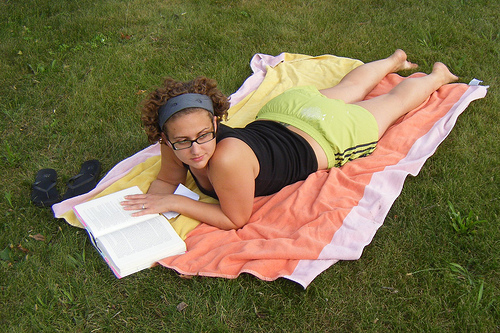<image>
Can you confirm if the girl is on the book? Yes. Looking at the image, I can see the girl is positioned on top of the book, with the book providing support. 